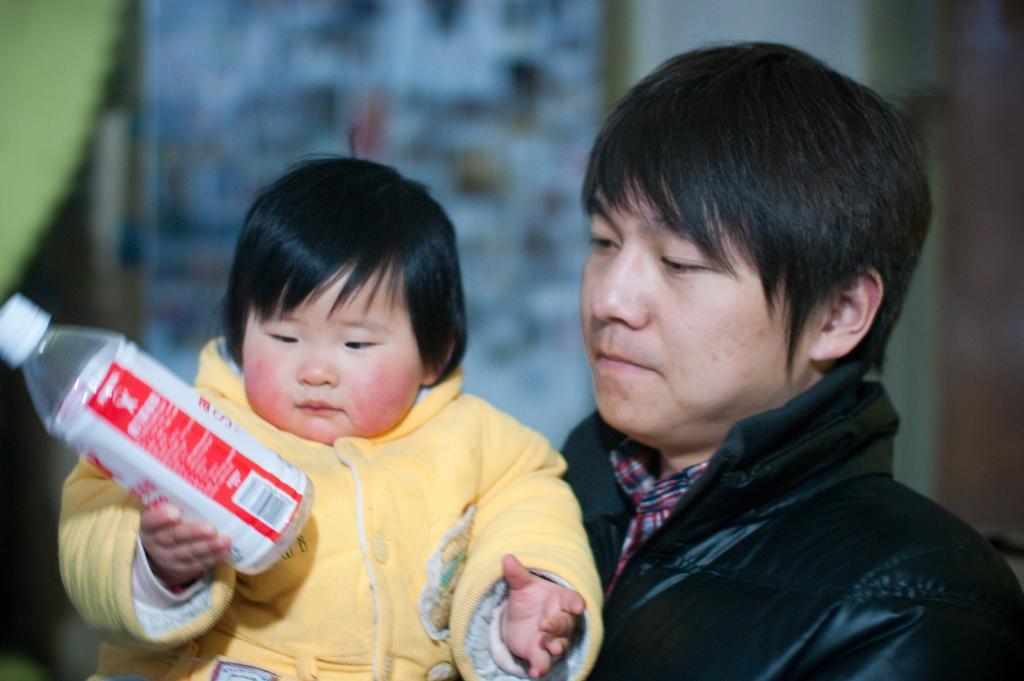Could you give a brief overview of what you see in this image? In this image we can see a man holding a baby in his hand and there is a bottle in the baby´s hand. 